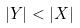Convert formula to latex. <formula><loc_0><loc_0><loc_500><loc_500>| Y | < | X |</formula> 